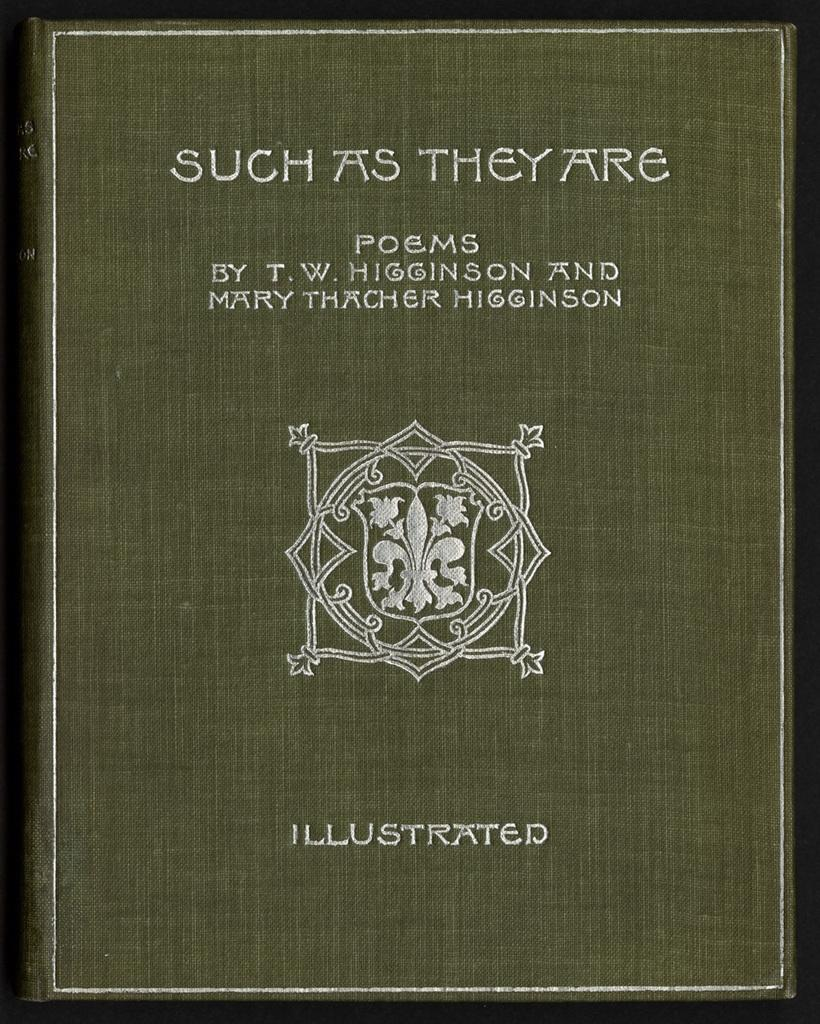<image>
Present a compact description of the photo's key features. Green book cover that has the word "Illustrated" on the bottom. 